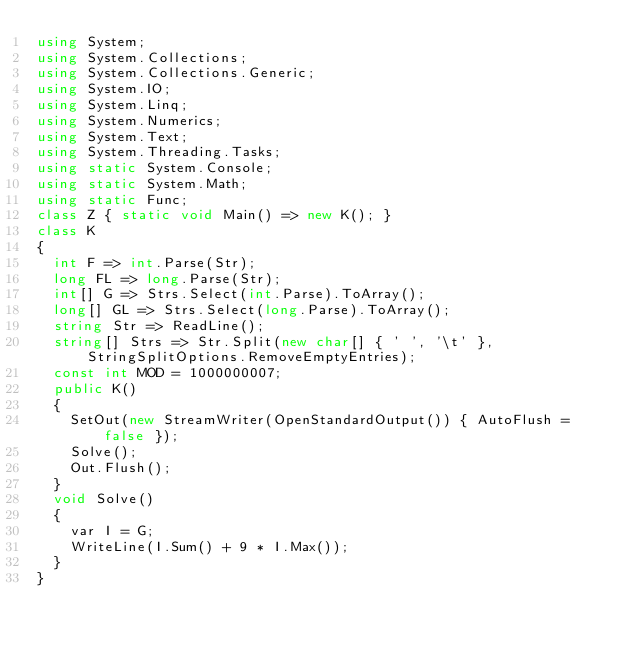<code> <loc_0><loc_0><loc_500><loc_500><_C#_>using System;
using System.Collections;
using System.Collections.Generic;
using System.IO;
using System.Linq;
using System.Numerics;
using System.Text;
using System.Threading.Tasks;
using static System.Console;
using static System.Math;
using static Func;
class Z { static void Main() => new K(); }
class K
{
	int F => int.Parse(Str);
	long FL => long.Parse(Str);
	int[] G => Strs.Select(int.Parse).ToArray();
	long[] GL => Strs.Select(long.Parse).ToArray();
	string Str => ReadLine();
	string[] Strs => Str.Split(new char[] { ' ', '\t' }, StringSplitOptions.RemoveEmptyEntries);
	const int MOD = 1000000007;
	public K()
	{
		SetOut(new StreamWriter(OpenStandardOutput()) { AutoFlush = false });
		Solve();
		Out.Flush();
	}
	void Solve()
	{
		var I = G;
		WriteLine(I.Sum() + 9 * I.Max());
	}
}
</code> 